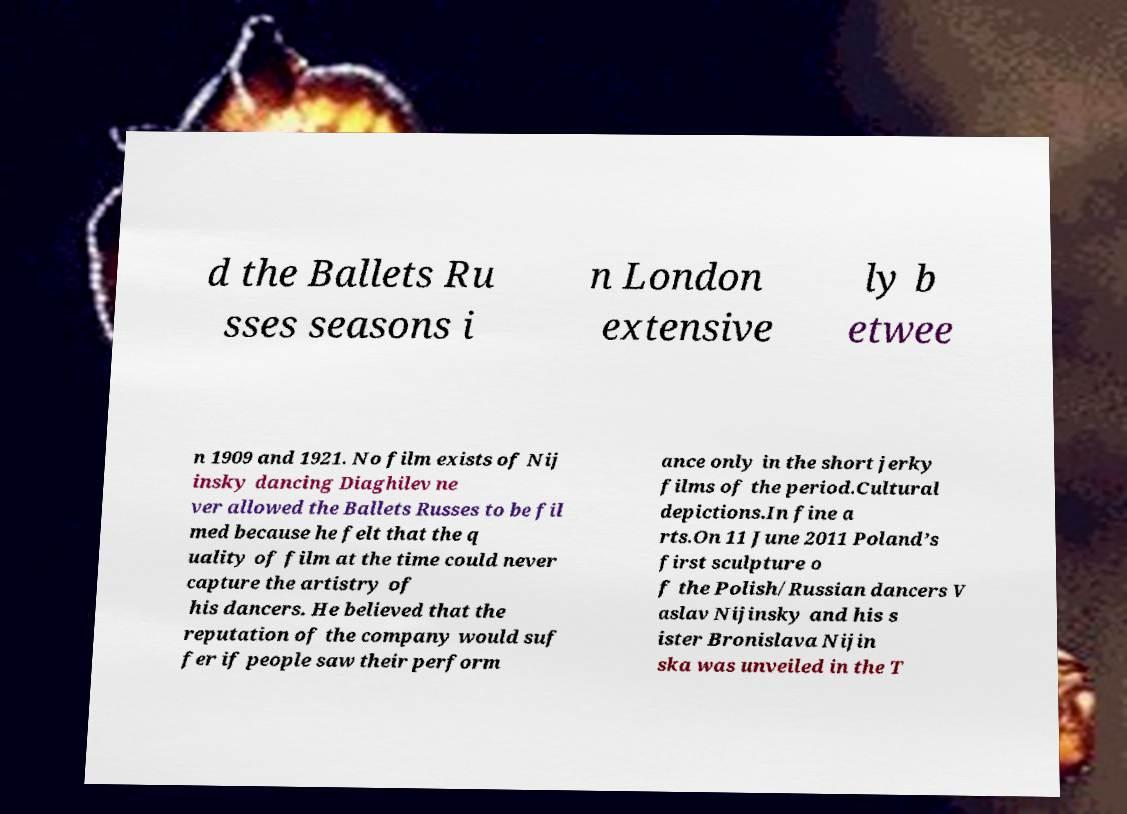For documentation purposes, I need the text within this image transcribed. Could you provide that? d the Ballets Ru sses seasons i n London extensive ly b etwee n 1909 and 1921. No film exists of Nij insky dancing Diaghilev ne ver allowed the Ballets Russes to be fil med because he felt that the q uality of film at the time could never capture the artistry of his dancers. He believed that the reputation of the company would suf fer if people saw their perform ance only in the short jerky films of the period.Cultural depictions.In fine a rts.On 11 June 2011 Poland’s first sculpture o f the Polish/Russian dancers V aslav Nijinsky and his s ister Bronislava Nijin ska was unveiled in the T 